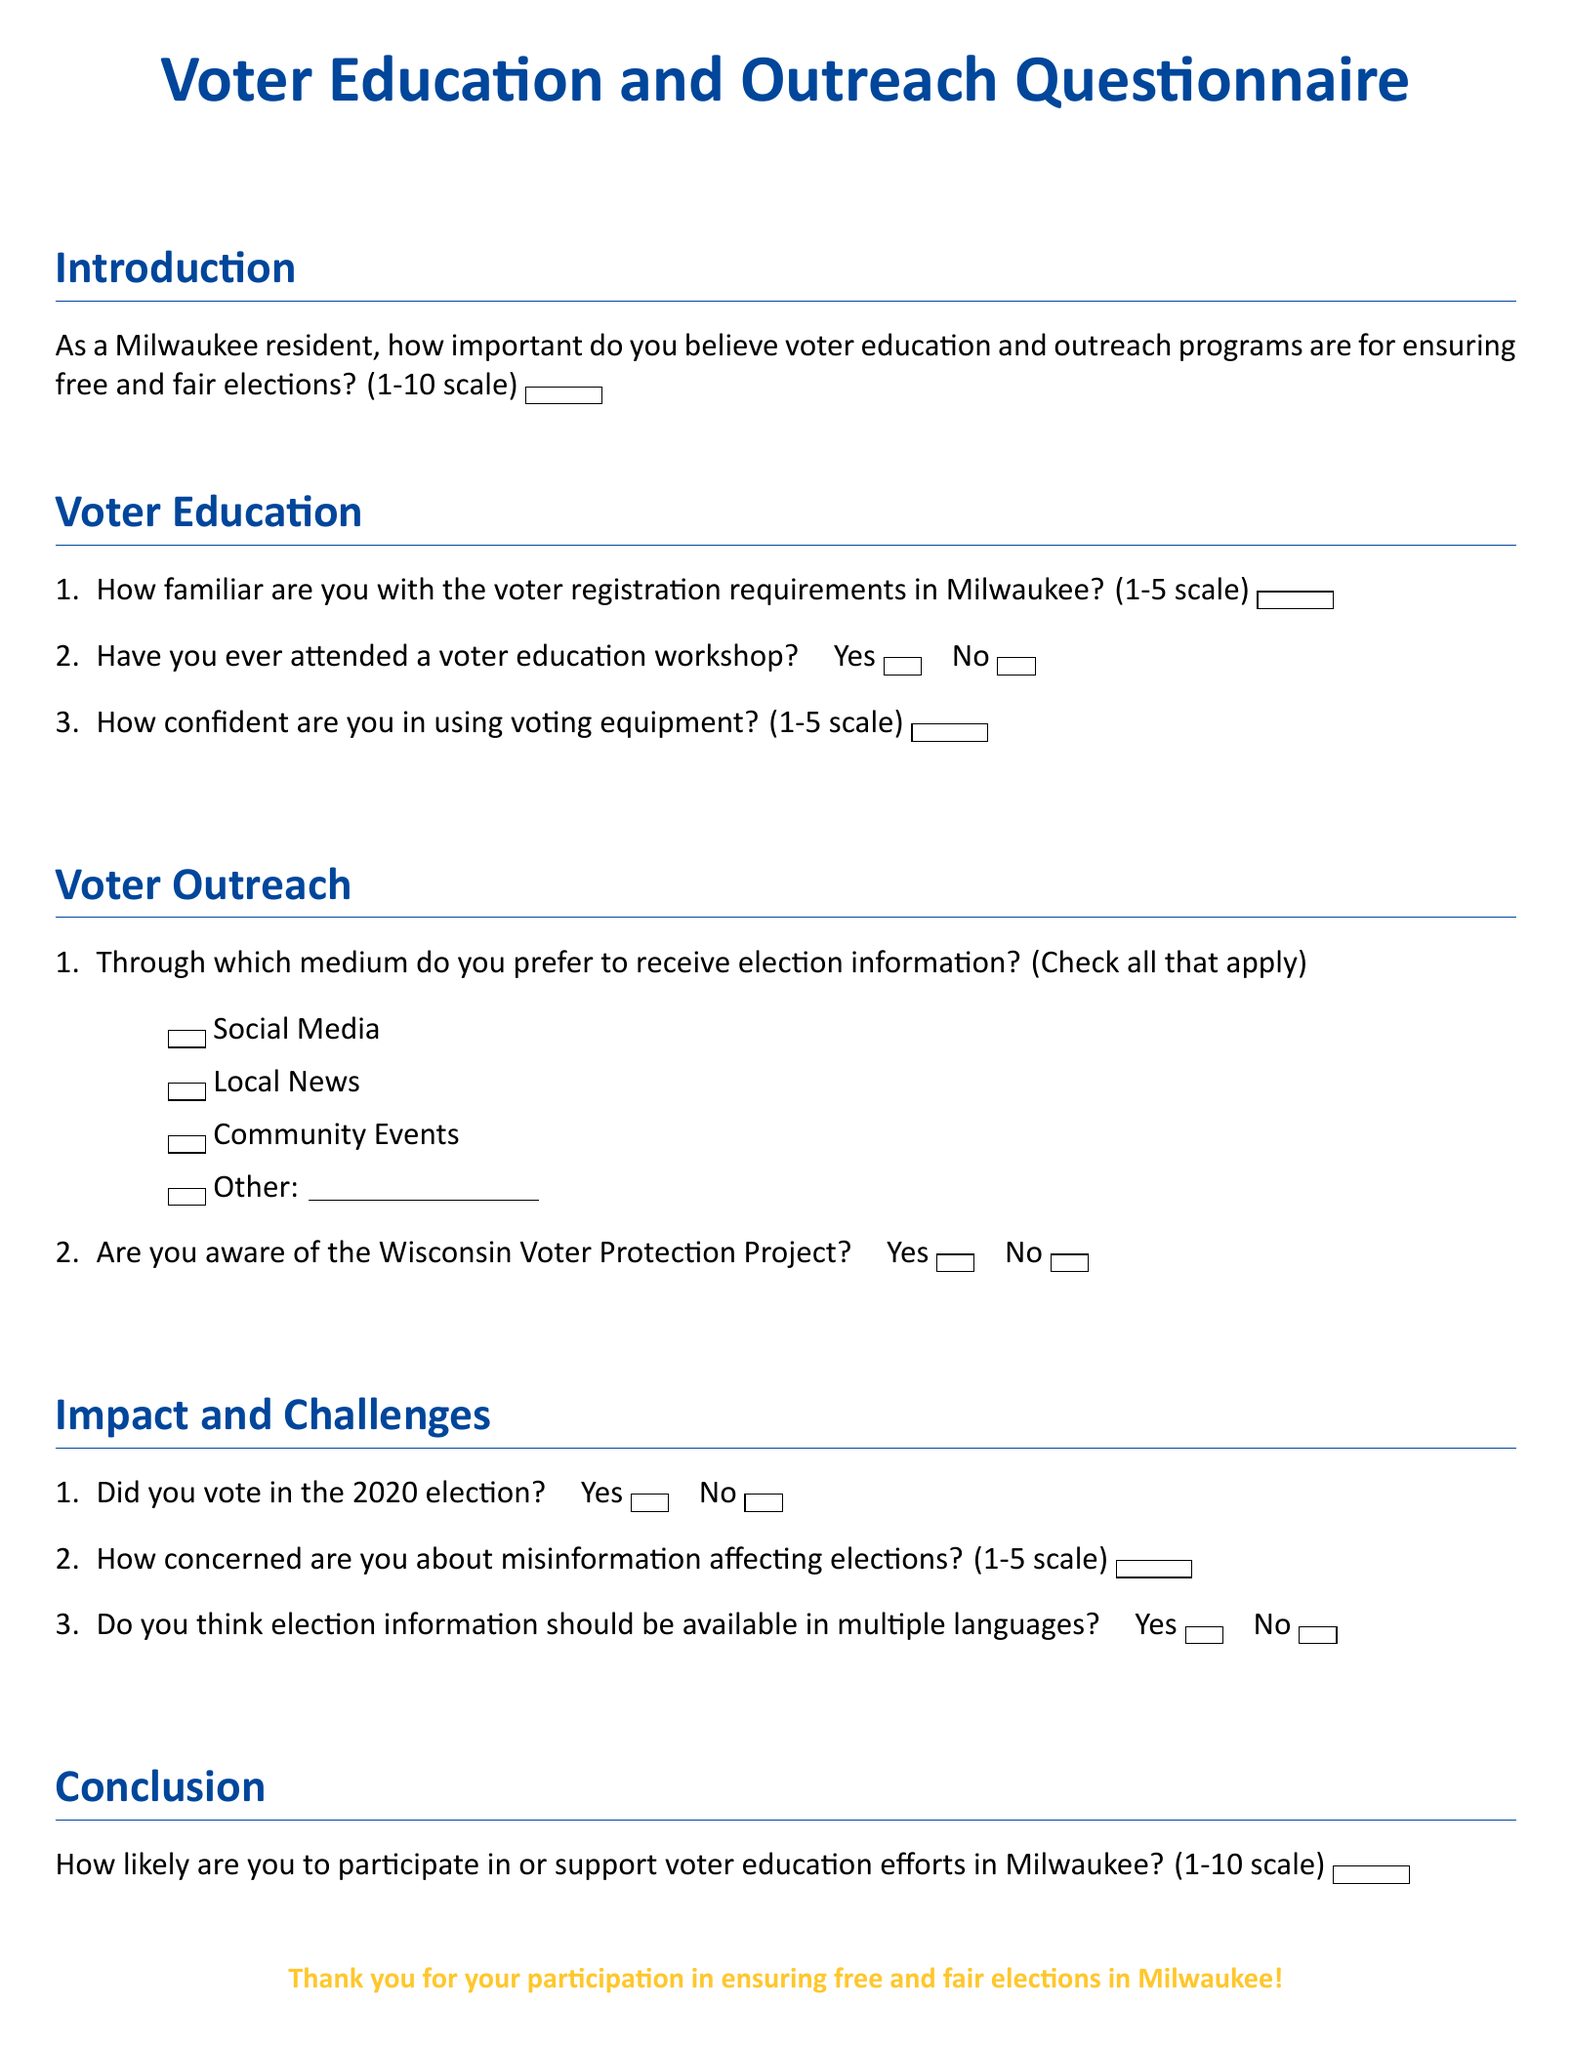What is the title of the document? The title is located at the top of the document and summarizes its purpose.
Answer: Voter Education and Outreach Questionnaire What is the scale used for rating the importance of voter education? The scale is mentioned in the introduction section of the document.
Answer: 1-10 scale How many sections are in the questionnaire? The number of sections can be counted from the layout of the document.
Answer: Four What is the maximum score on the confidence scale for using voting equipment? The maximum score is mentioned as part of a specific question in the voter education section.
Answer: 5 Is there a question about attendance at voter education workshops? The presence of the question about workshops confirms its inclusion in the document.
Answer: Yes What language availability for election information is questioned? The document includes a specific question regarding language access for election information.
Answer: Multiple languages What is the color used for the header of the title? The color of the heading is specified in the document's formatting.
Answer: Milwaukee blue How concerned are respondents asked to rate misinformation affecting elections? This is assessed on a specific 1-5 scale provided in the impact section of the questionnaire.
Answer: 1-5 scale 